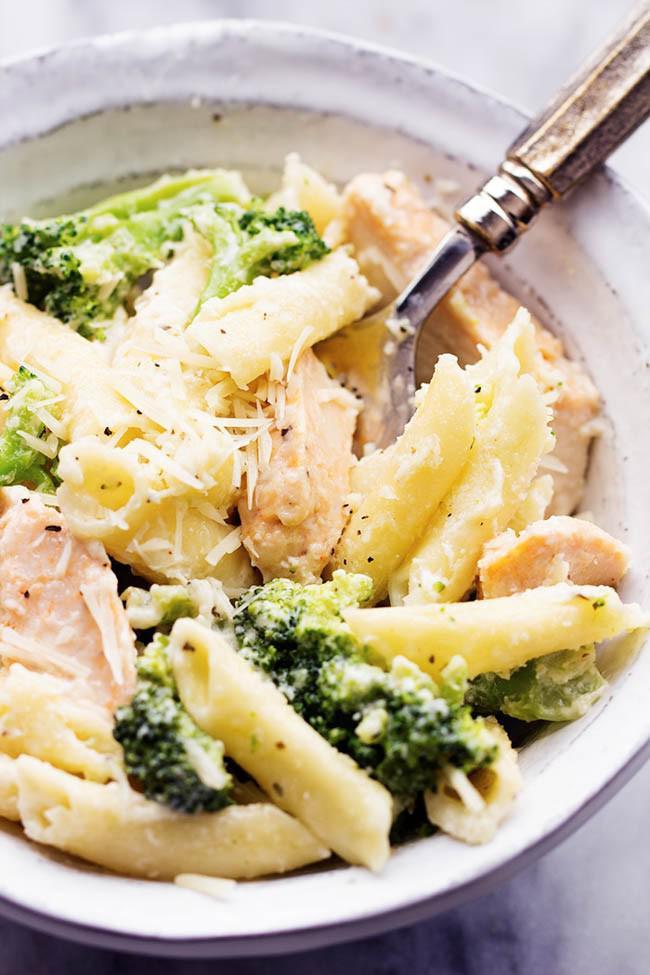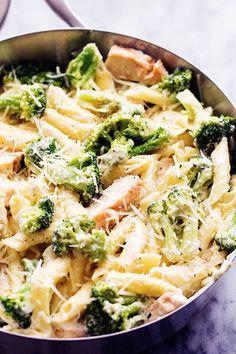The first image is the image on the left, the second image is the image on the right. Analyze the images presented: Is the assertion "A metalic spoon is in one of the food." valid? Answer yes or no. Yes. The first image is the image on the left, the second image is the image on the right. Evaluate the accuracy of this statement regarding the images: "There is a serving utensil in the dish on the right.". Is it true? Answer yes or no. No. 